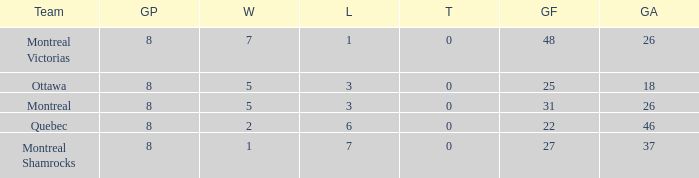For teams with fewer than 5 wins, goals against over 37, and fewer than 8 games played, what is the average number of ties? None. 